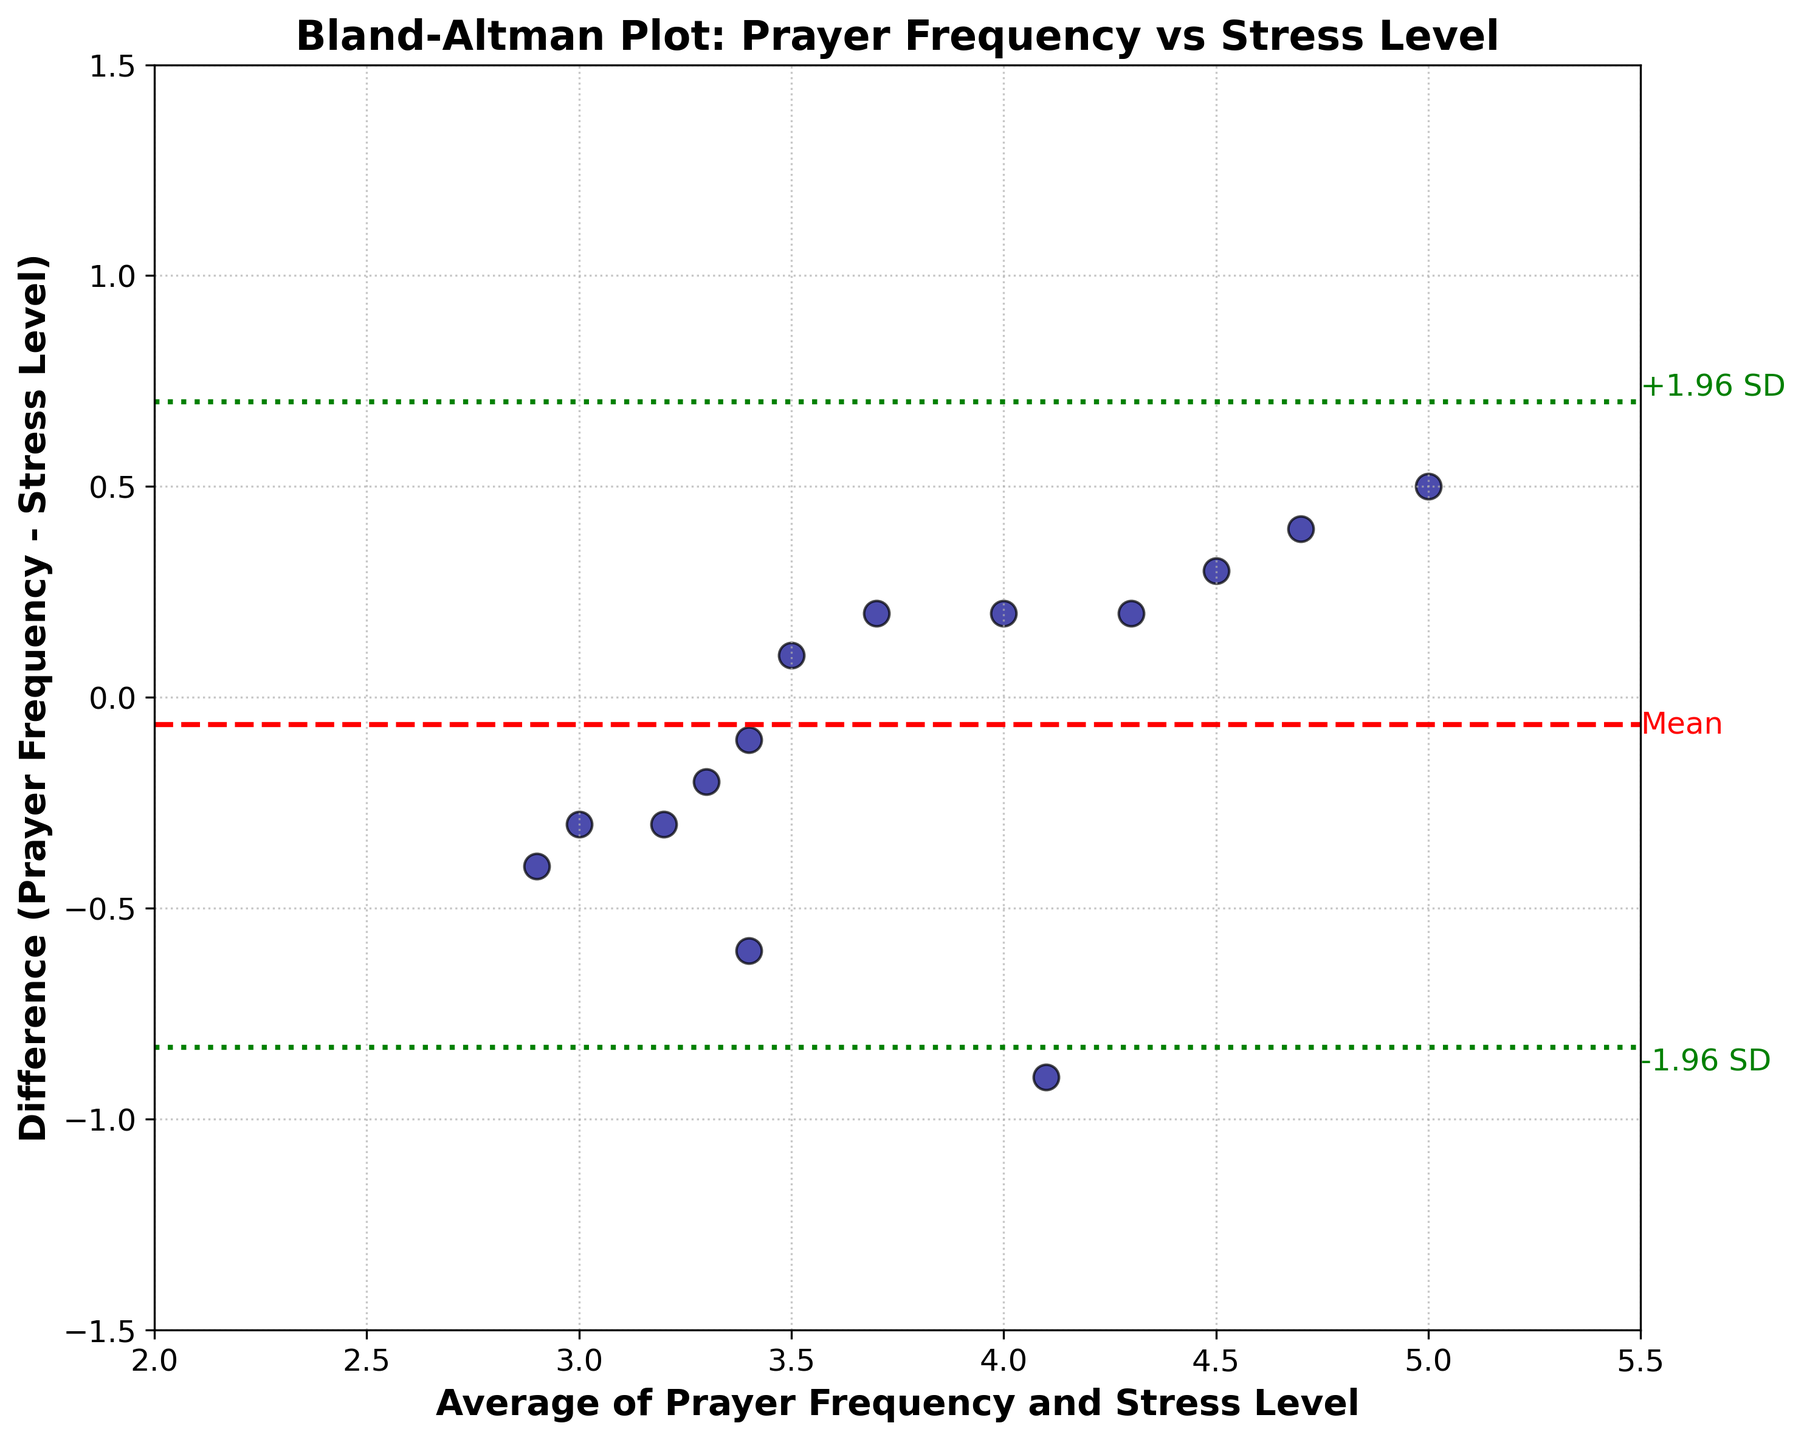What is the title of the plot? The title of the plot is located at the top of the figure. It reads: "Bland-Altman Plot: Prayer Frequency vs Stress Level".
Answer: "Bland-Altman Plot: Prayer Frequency vs Stress Level" What are the labels of the x-axis and y-axis? The x-axis label is "Average of Prayer Frequency and Stress Level", and the y-axis label is "Difference (Prayer Frequency - Stress Level)" as indicated by the text beside each axis.
Answer: "Average of Prayer Frequency and Stress Level", "Difference (Prayer Frequency - Stress Level)" How many data points are plotted in the scatter plot? By counting each dark blue marker on the plot, you can see there are 14 data points.
Answer: 14 What is the color of the mean difference line in the plot? The mean difference line is represented by the red dashed line in the plot.
Answer: Red Where are the limits of agreement lines located on the plot? The limits of agreement are represented by green dotted lines. They are located at the mean difference ± 1.96 times the standard deviation of the differences.
Answer: Mean ± 1.96 SD What is the mean difference between prayer frequency and stress level? The mean difference is represented by the red dashed line. Since the line is labeled as 'Mean', you can read its position on the y-axis, which is around 0.07.
Answer: 0.07 Which prayer frequency has the largest negative difference? Looking at the data points on the left side (negative difference), the prayer frequency labeled 'Daily' has the largest negative difference at -0.9.
Answer: Daily Which prayer frequency has the smallest positive difference? By examining the data points above the x-axis, 'Thrice weekly' has the smallest positive difference at 0.1.
Answer: Thrice weekly What are the upper and lower limits of agreement? The upper limit is the mean + 1.96 * SD, and the lower limit is the mean - 1.96 * SD. On the plot, these can be seen as the green dotted lines, approximately at y-values of 0.67 and -0.53.
Answer: 0.67, -0.53 